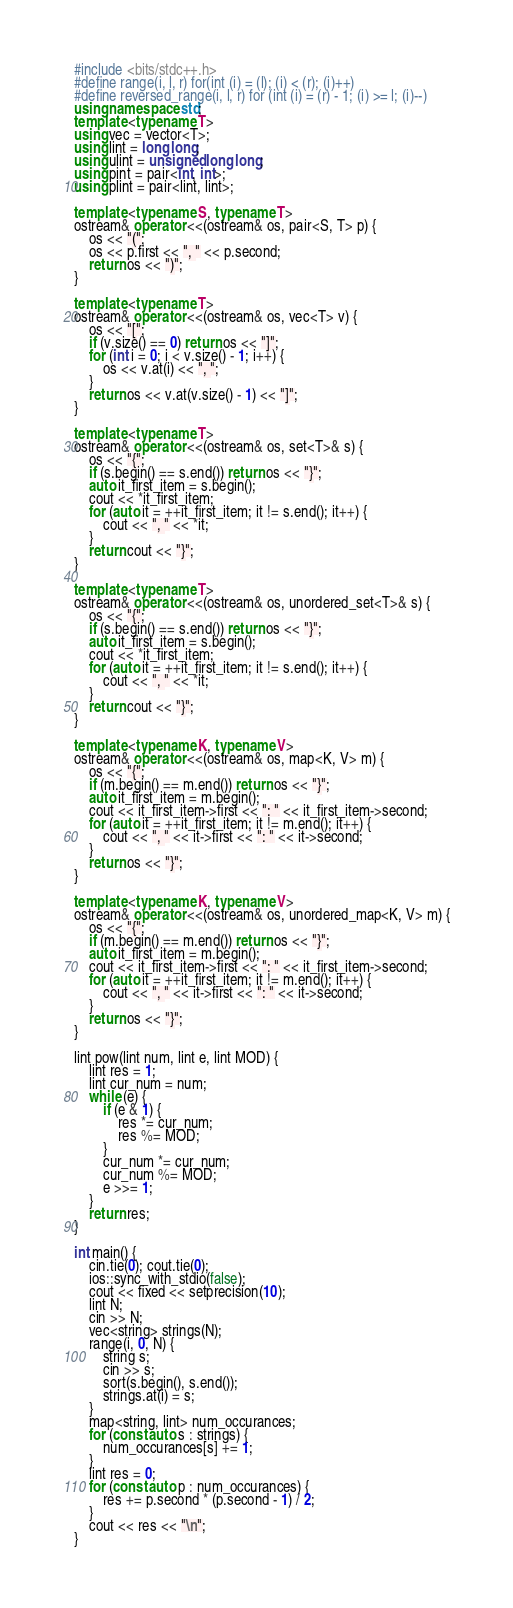Convert code to text. <code><loc_0><loc_0><loc_500><loc_500><_C++_>#include <bits/stdc++.h>
#define range(i, l, r) for(int (i) = (l); (i) < (r); (i)++)
#define reversed_range(i, l, r) for (int (i) = (r) - 1; (i) >= l; (i)--)
using namespace std;
template <typename T>
using vec = vector<T>;
using lint = long long;
using ulint = unsigned long long;
using pint = pair<int, int>;
using plint = pair<lint, lint>;

template <typename S, typename T>
ostream& operator <<(ostream& os, pair<S, T> p) {
    os << "(";
    os << p.first << ", " << p.second;
    return os << ")";
}

template <typename T>
ostream& operator <<(ostream& os, vec<T> v) {
    os << "[";
    if (v.size() == 0) return os << "]";
    for (int i = 0; i < v.size() - 1; i++) {
        os << v.at(i) << ", ";
    }
    return os << v.at(v.size() - 1) << "]";
}

template <typename T>
ostream& operator <<(ostream& os, set<T>& s) {
    os << "{";
    if (s.begin() == s.end()) return os << "}";
    auto it_first_item = s.begin();
    cout << *it_first_item;
    for (auto it = ++it_first_item; it != s.end(); it++) {
        cout << ", " << *it;
    }
    return cout << "}";
}

template <typename T>
ostream& operator <<(ostream& os, unordered_set<T>& s) {
    os << "{";
    if (s.begin() == s.end()) return os << "}";
    auto it_first_item = s.begin();
    cout << *it_first_item;
    for (auto it = ++it_first_item; it != s.end(); it++) {
        cout << ", " << *it;
    }
    return cout << "}";
}

template <typename K, typename V>
ostream& operator <<(ostream& os, map<K, V> m) {
    os << "{";
    if (m.begin() == m.end()) return os << "}";
    auto it_first_item = m.begin();
    cout << it_first_item->first << ": " << it_first_item->second;
    for (auto it = ++it_first_item; it != m.end(); it++) {
        cout << ", " << it->first << ": " << it->second;
    }
    return os << "}";
}

template <typename K, typename V>
ostream& operator <<(ostream& os, unordered_map<K, V> m) {
    os << "{";
    if (m.begin() == m.end()) return os << "}";
    auto it_first_item = m.begin();
    cout << it_first_item->first << ": " << it_first_item->second;
    for (auto it = ++it_first_item; it != m.end(); it++) {
        cout << ", " << it->first << ": " << it->second;
    }
    return os << "}";
}

lint pow(lint num, lint e, lint MOD) {
    lint res = 1;
    lint cur_num = num;
    while (e) {
        if (e & 1) {
            res *= cur_num;
            res %= MOD;
        }
        cur_num *= cur_num;
        cur_num %= MOD;
        e >>= 1;
    }
    return res;
}

int main() {
    cin.tie(0); cout.tie(0);
    ios::sync_with_stdio(false);
    cout << fixed << setprecision(10);
    lint N;
    cin >> N;
    vec<string> strings(N);
    range(i, 0, N) {
        string s;
        cin >> s;
        sort(s.begin(), s.end());
        strings.at(i) = s;
    }
    map<string, lint> num_occurances;
    for (const auto s : strings) {
        num_occurances[s] += 1;
    }
    lint res = 0;
    for (const auto p : num_occurances) {
        res += p.second * (p.second - 1) / 2;
    }
    cout << res << "\n";
}</code> 